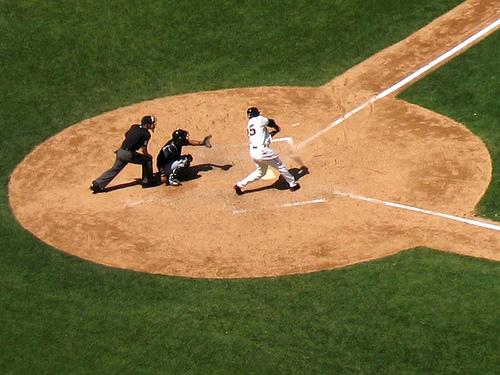Is the guy in white the winner of the game?
Answer briefly. Yes. What sport is shown?
Answer briefly. Baseball. Is the grass green?
Give a very brief answer. Yes. 